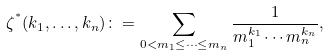<formula> <loc_0><loc_0><loc_500><loc_500>\zeta ^ { ^ { * } } ( k _ { 1 } , \dots , k _ { n } ) \colon = \sum _ { 0 < m _ { 1 } { \leq } \cdots { \leq } m _ { n } } \frac { 1 } { m _ { 1 } ^ { k _ { 1 } } \cdots m _ { n } ^ { k _ { n } } } ,</formula> 